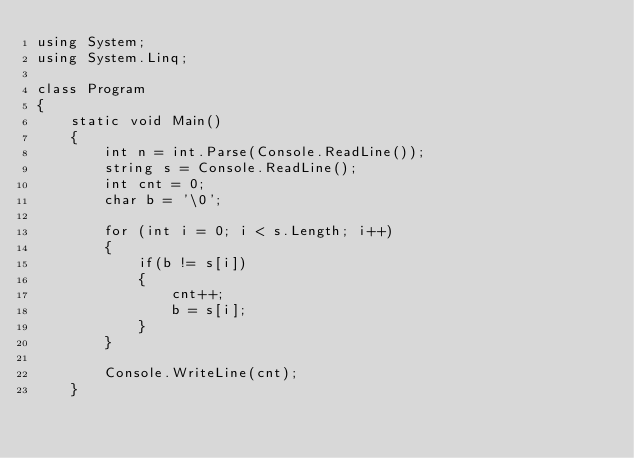Convert code to text. <code><loc_0><loc_0><loc_500><loc_500><_C#_>using System;
using System.Linq;

class Program
{
    static void Main()
    {
        int n = int.Parse(Console.ReadLine());
        string s = Console.ReadLine();
        int cnt = 0;
        char b = '\0';
       
        for (int i = 0; i < s.Length; i++)
        {
            if(b != s[i])
            {
                cnt++;
                b = s[i];
            }
        }

        Console.WriteLine(cnt);
    }</code> 